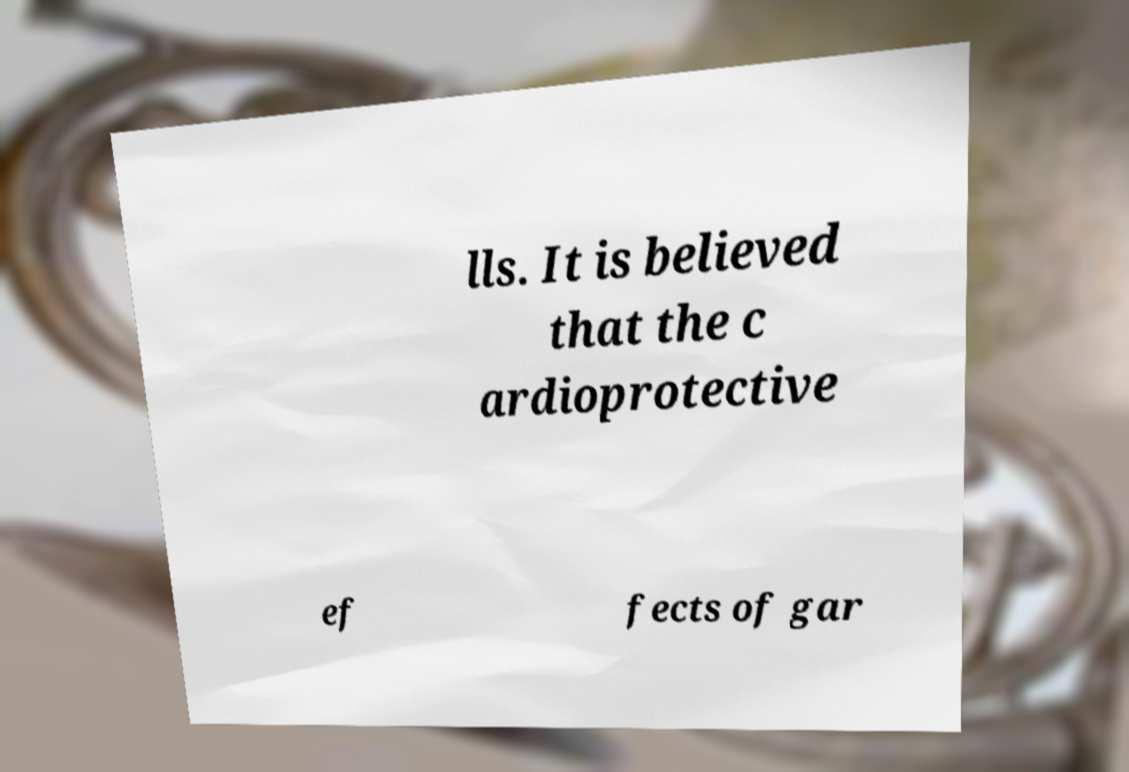What messages or text are displayed in this image? I need them in a readable, typed format. lls. It is believed that the c ardioprotective ef fects of gar 